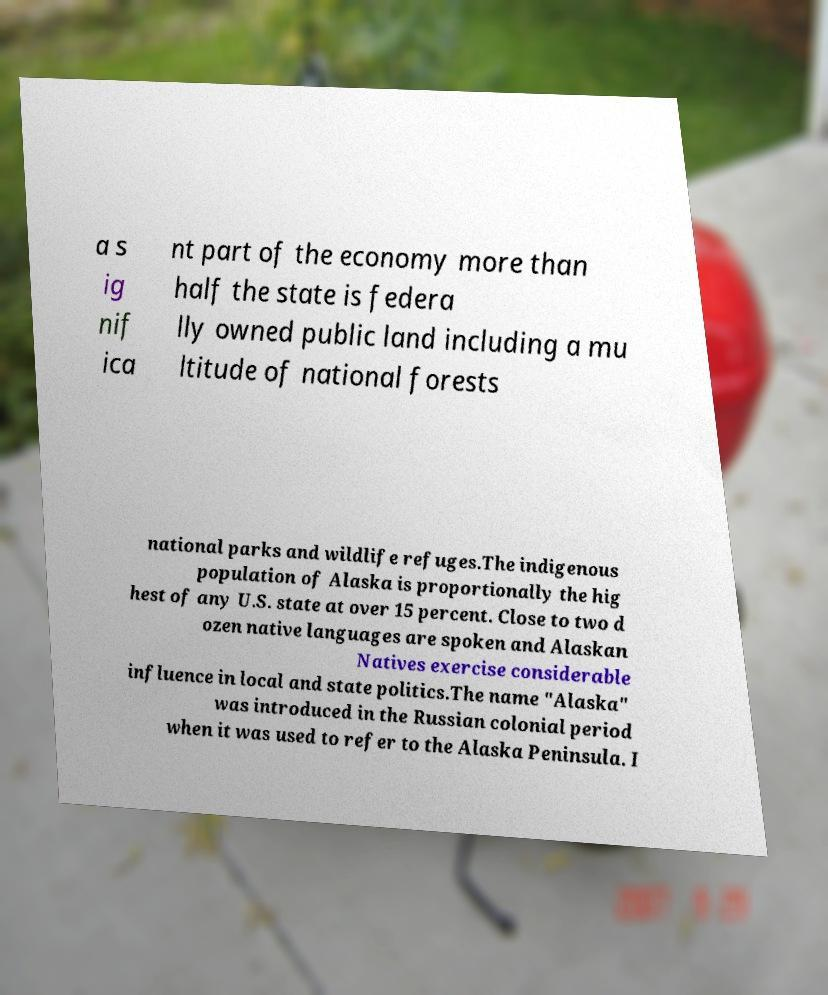There's text embedded in this image that I need extracted. Can you transcribe it verbatim? a s ig nif ica nt part of the economy more than half the state is federa lly owned public land including a mu ltitude of national forests national parks and wildlife refuges.The indigenous population of Alaska is proportionally the hig hest of any U.S. state at over 15 percent. Close to two d ozen native languages are spoken and Alaskan Natives exercise considerable influence in local and state politics.The name "Alaska" was introduced in the Russian colonial period when it was used to refer to the Alaska Peninsula. I 